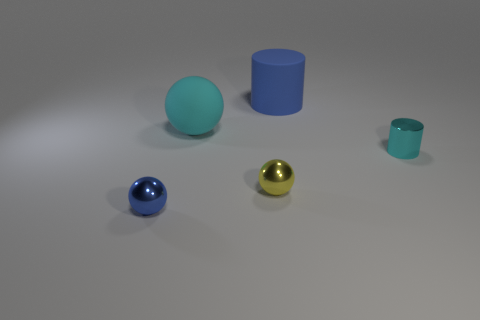What number of cyan spheres are the same size as the yellow metal object?
Your answer should be very brief. 0. There is a cyan object that is left of the cyan cylinder; does it have the same shape as the blue object behind the small metal cylinder?
Make the answer very short. No. What material is the cylinder that is behind the ball that is behind the small metallic thing that is behind the yellow shiny object?
Ensure brevity in your answer.  Rubber. What is the shape of the thing that is the same size as the blue rubber cylinder?
Provide a succinct answer. Sphere. Are there any other tiny metal cylinders of the same color as the small shiny cylinder?
Your answer should be compact. No. The blue ball has what size?
Ensure brevity in your answer.  Small. Are the big cyan thing and the tiny cyan object made of the same material?
Your answer should be very brief. No. How many matte objects are in front of the small sphere that is on the right side of the metal thing that is to the left of the tiny yellow sphere?
Provide a short and direct response. 0. What shape is the cyan thing on the left side of the small cyan thing?
Offer a very short reply. Sphere. What number of other objects are the same material as the cyan cylinder?
Your response must be concise. 2. 